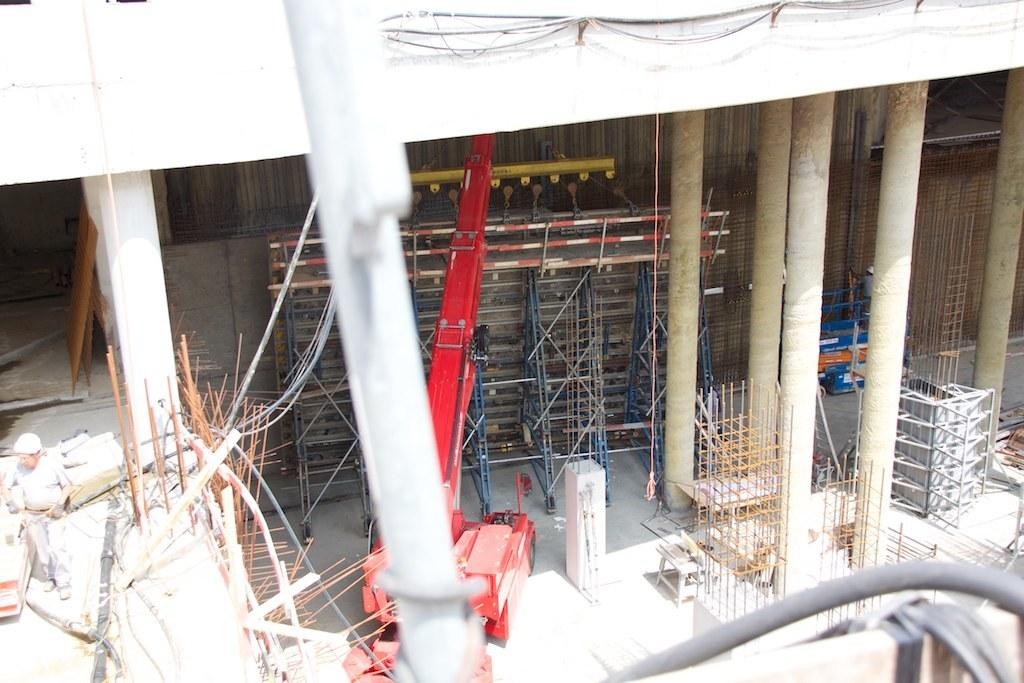What is happening in the image? The image shows the construction of a building. What materials can be seen in the image? There are rods and pillars visible in the image. What equipment is being used in the construction process? There is a crane in the image. Can you describe the person involved in the construction? A person wearing a helmet is visible on the left side of the image. What type of story is the goat telling the person wearing a helmet in the image? There is no goat present in the image, so it is not possible to determine if a story is being told or to whom. 